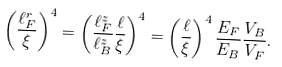Convert formula to latex. <formula><loc_0><loc_0><loc_500><loc_500>\left ( \frac { \ell _ { F } ^ { r } } { \xi } \right ) ^ { 4 } = \left ( \frac { \ell _ { F } ^ { z } } { \ell _ { B } ^ { z } } \frac { \ell } { \xi } \right ) ^ { 4 } = \left ( \frac { \ell } { \xi } \right ) ^ { 4 } \frac { E _ { F } } { E _ { B } } \frac { V _ { B } } { V _ { F } } .</formula> 